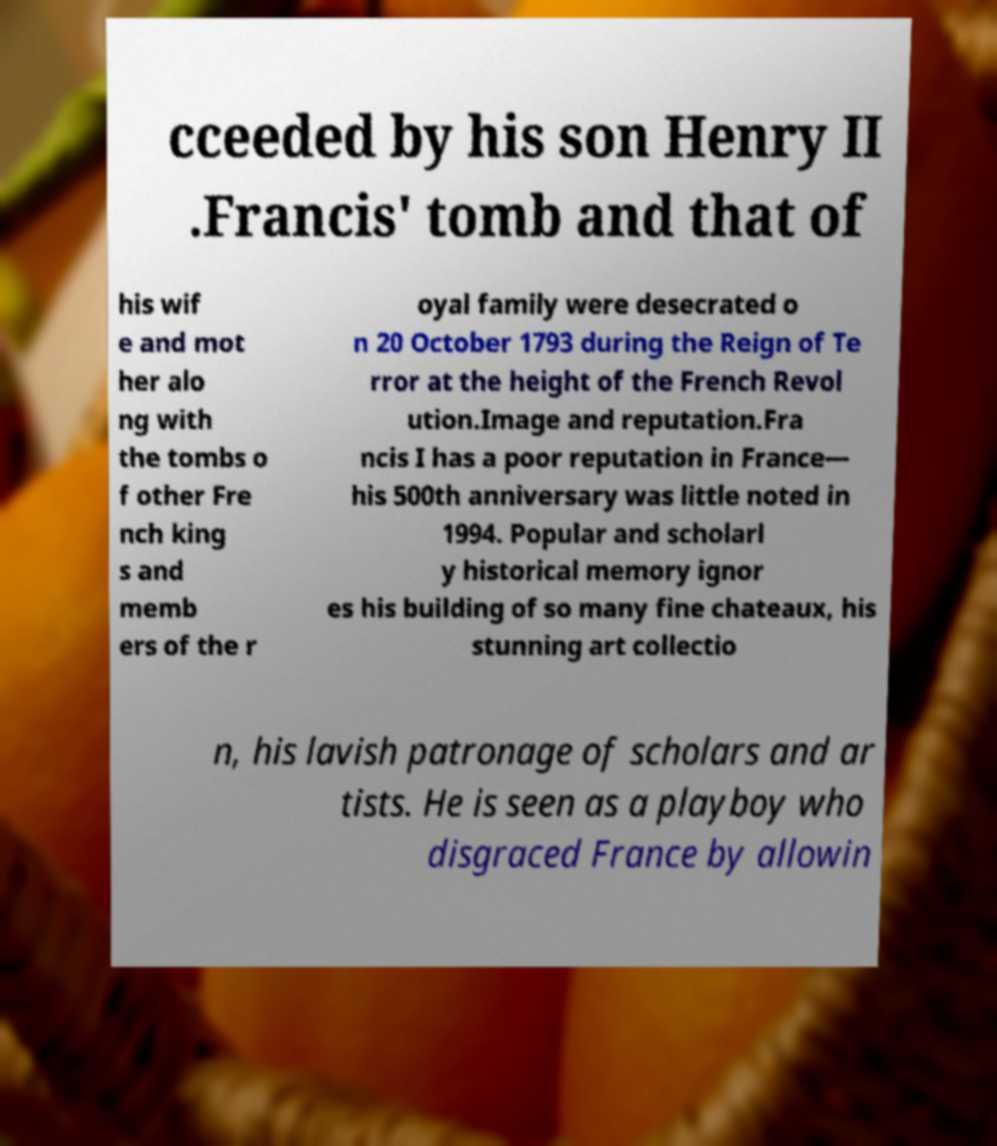What messages or text are displayed in this image? I need them in a readable, typed format. cceeded by his son Henry II .Francis' tomb and that of his wif e and mot her alo ng with the tombs o f other Fre nch king s and memb ers of the r oyal family were desecrated o n 20 October 1793 during the Reign of Te rror at the height of the French Revol ution.Image and reputation.Fra ncis I has a poor reputation in France— his 500th anniversary was little noted in 1994. Popular and scholarl y historical memory ignor es his building of so many fine chateaux, his stunning art collectio n, his lavish patronage of scholars and ar tists. He is seen as a playboy who disgraced France by allowin 